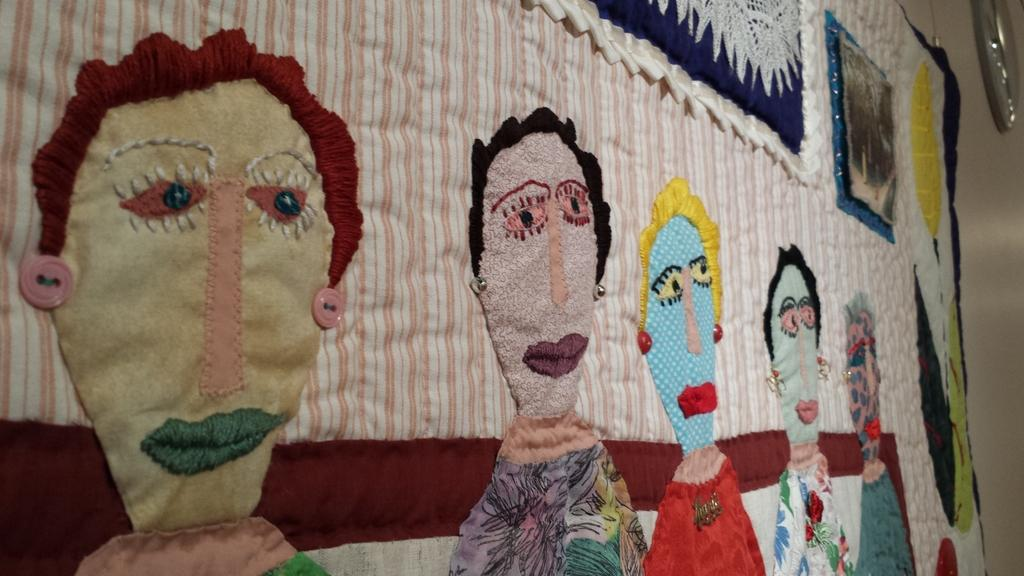What is the main subject in the center of the image? There is an embroidery cloth in the center of the image. Where is the embroidery cloth located? The embroidery cloth is on the wall. What can be seen in the background of the image? There is a wall and a clock in the background of the image. How many snails are crawling on the embroidery cloth in the image? There are no snails present in the image; the embroidery cloth is on the wall without any snails. What type of punishment is being depicted in the embroidery cloth? The embroidery cloth does not depict any punishment; it is a decorative piece on the wall. 